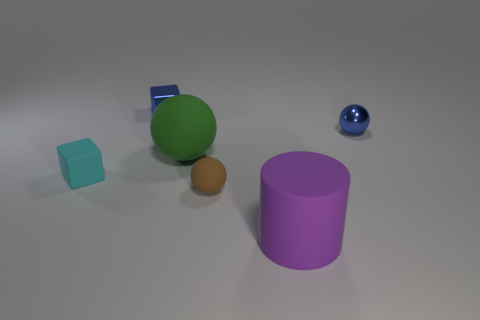Subtract all green matte spheres. How many spheres are left? 2 Add 1 brown objects. How many objects exist? 7 Subtract all purple balls. Subtract all blue cylinders. How many balls are left? 3 Subtract all cubes. How many objects are left? 4 Add 1 cyan objects. How many cyan objects are left? 2 Add 2 small brown rubber balls. How many small brown rubber balls exist? 3 Subtract 1 blue cubes. How many objects are left? 5 Subtract all red cylinders. Subtract all tiny rubber cubes. How many objects are left? 5 